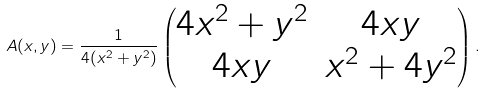Convert formula to latex. <formula><loc_0><loc_0><loc_500><loc_500>A ( x , y ) = \frac { 1 } { 4 ( x ^ { 2 } + y ^ { 2 } ) } \begin{pmatrix} 4 x ^ { 2 } + y ^ { 2 } & 4 x y \\ 4 x y & x ^ { 2 } + 4 y ^ { 2 } \end{pmatrix} .</formula> 